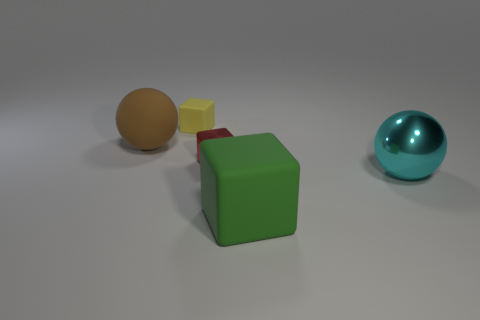There is a green cube that is the same material as the tiny yellow cube; what size is it?
Your answer should be compact. Large. What number of other large objects have the same shape as the big brown object?
Your answer should be compact. 1. Are there more rubber blocks that are to the right of the big cyan shiny object than rubber spheres?
Your answer should be compact. No. What shape is the thing that is both on the left side of the large green thing and in front of the brown ball?
Make the answer very short. Cube. Does the green rubber object have the same size as the red metallic object?
Ensure brevity in your answer.  No. How many yellow matte blocks are in front of the big matte ball?
Ensure brevity in your answer.  0. Are there the same number of small red objects that are behind the rubber ball and small red cubes on the left side of the yellow thing?
Offer a very short reply. Yes. There is a large thing that is on the left side of the small yellow matte cube; is its shape the same as the cyan metallic object?
Give a very brief answer. Yes. Are there any other things that have the same material as the big green block?
Provide a succinct answer. Yes. There is a brown object; is it the same size as the rubber block on the left side of the big green matte block?
Offer a terse response. No. 